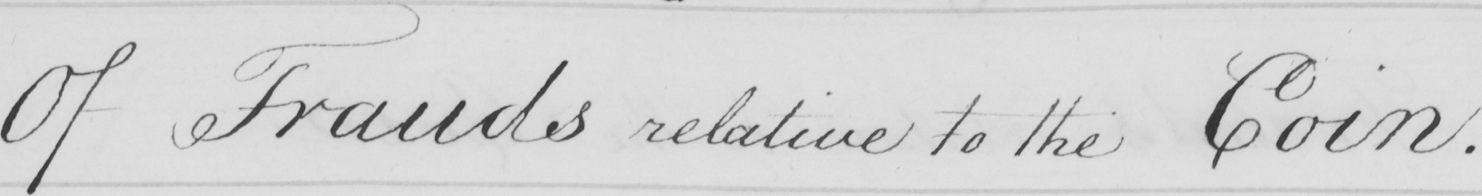What is written in this line of handwriting? Of Frauds relative to the Coin . 